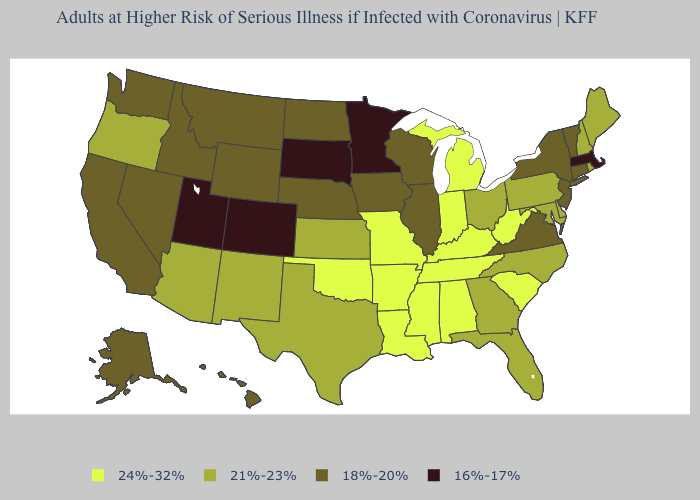Name the states that have a value in the range 24%-32%?
Be succinct. Alabama, Arkansas, Indiana, Kentucky, Louisiana, Michigan, Mississippi, Missouri, Oklahoma, South Carolina, Tennessee, West Virginia. What is the lowest value in states that border Connecticut?
Be succinct. 16%-17%. What is the lowest value in the USA?
Answer briefly. 16%-17%. Name the states that have a value in the range 24%-32%?
Quick response, please. Alabama, Arkansas, Indiana, Kentucky, Louisiana, Michigan, Mississippi, Missouri, Oklahoma, South Carolina, Tennessee, West Virginia. What is the value of Wyoming?
Give a very brief answer. 18%-20%. What is the lowest value in the USA?
Give a very brief answer. 16%-17%. What is the value of Illinois?
Write a very short answer. 18%-20%. Name the states that have a value in the range 21%-23%?
Give a very brief answer. Arizona, Delaware, Florida, Georgia, Kansas, Maine, Maryland, New Hampshire, New Mexico, North Carolina, Ohio, Oregon, Pennsylvania, Rhode Island, Texas. What is the highest value in the USA?
Short answer required. 24%-32%. Among the states that border Texas , which have the lowest value?
Concise answer only. New Mexico. Name the states that have a value in the range 18%-20%?
Give a very brief answer. Alaska, California, Connecticut, Hawaii, Idaho, Illinois, Iowa, Montana, Nebraska, Nevada, New Jersey, New York, North Dakota, Vermont, Virginia, Washington, Wisconsin, Wyoming. What is the value of Texas?
Quick response, please. 21%-23%. Does Massachusetts have the lowest value in the Northeast?
Give a very brief answer. Yes. Name the states that have a value in the range 18%-20%?
Write a very short answer. Alaska, California, Connecticut, Hawaii, Idaho, Illinois, Iowa, Montana, Nebraska, Nevada, New Jersey, New York, North Dakota, Vermont, Virginia, Washington, Wisconsin, Wyoming. What is the value of Iowa?
Keep it brief. 18%-20%. 